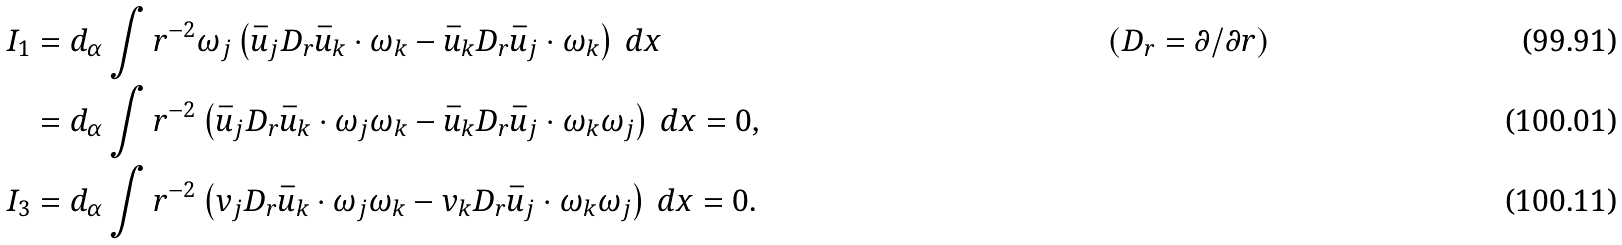<formula> <loc_0><loc_0><loc_500><loc_500>I _ { 1 } & = d _ { \alpha } \int r ^ { - 2 } \omega _ { j } \left ( \bar { u } _ { j } D _ { r } \bar { u } _ { k } \cdot \omega _ { k } - \bar { u } _ { k } D _ { r } \bar { u } _ { j } \cdot \omega _ { k } \right ) \, d x & & ( D _ { r } = \partial / \partial r ) \\ & = d _ { \alpha } \int r ^ { - 2 } \left ( \bar { u } _ { j } D _ { r } \bar { u } _ { k } \cdot \omega _ { j } \omega _ { k } - \bar { u } _ { k } D _ { r } \bar { u } _ { j } \cdot \omega _ { k } \omega _ { j } \right ) \, d x = 0 , \\ I _ { 3 } & = d _ { \alpha } \int r ^ { - 2 } \left ( v _ { j } D _ { r } \bar { u } _ { k } \cdot \omega _ { j } \omega _ { k } - v _ { k } D _ { r } \bar { u } _ { j } \cdot \omega _ { k } \omega _ { j } \right ) \, d x = 0 .</formula> 